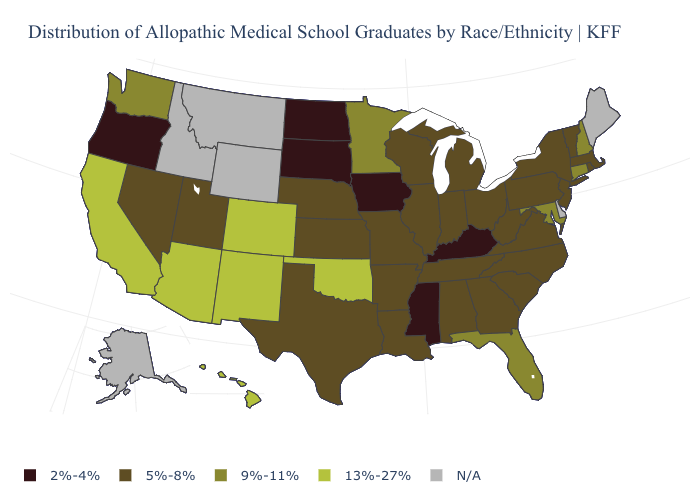What is the value of New York?
Write a very short answer. 5%-8%. Name the states that have a value in the range 13%-27%?
Short answer required. Arizona, California, Colorado, Hawaii, New Mexico, Oklahoma. Name the states that have a value in the range 2%-4%?
Be succinct. Iowa, Kentucky, Mississippi, North Dakota, Oregon, South Dakota. What is the value of New York?
Short answer required. 5%-8%. What is the value of Missouri?
Answer briefly. 5%-8%. Among the states that border Wisconsin , does Michigan have the highest value?
Keep it brief. No. What is the lowest value in the USA?
Short answer required. 2%-4%. Does Michigan have the lowest value in the MidWest?
Concise answer only. No. What is the lowest value in the South?
Write a very short answer. 2%-4%. Name the states that have a value in the range 9%-11%?
Keep it brief. Connecticut, Florida, Maryland, Minnesota, New Hampshire, Washington. What is the value of New York?
Keep it brief. 5%-8%. Name the states that have a value in the range 2%-4%?
Concise answer only. Iowa, Kentucky, Mississippi, North Dakota, Oregon, South Dakota. 